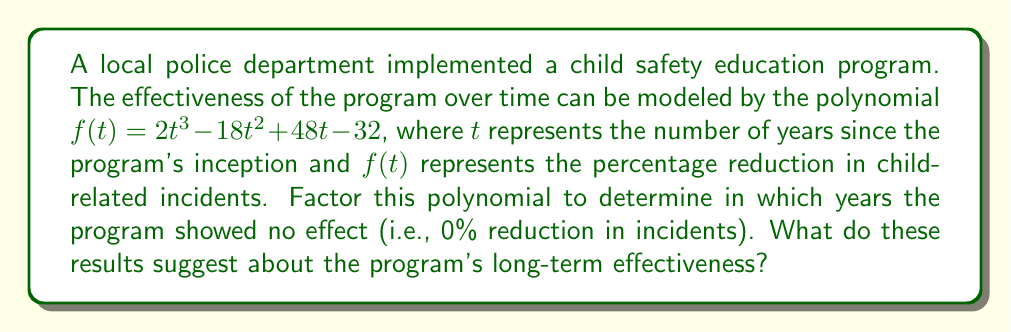Can you answer this question? To solve this problem, we need to factor the given polynomial and find its roots. The roots will represent the years when the program showed no effect.

1) First, let's try to factor out any common factors:
   $f(t) = 2t^3 - 18t^2 + 48t - 32$
   There are no common factors for all terms.

2) Next, we can try the rational root theorem. The possible rational roots are the factors of the constant term (32): ±1, ±2, ±4, ±8, ±16, ±32.

3) Testing these values, we find that $t = 2$ is a root. So $(t - 2)$ is a factor.

4) Divide the polynomial by $(t - 2)$:
   $\frac{2t^3 - 18t^2 + 48t - 32}{t - 2} = 2t^2 - 14t + 16$

5) The quadratic $2t^2 - 14t + 16$ can be factored further:
   $2t^2 - 14t + 16 = 2(t^2 - 7t + 8) = 2(t - 4)(t - 3)$

6) Therefore, the complete factorization is:
   $f(t) = 2(t - 2)(t - 3)(t - 4)$

7) The roots of this polynomial are $t = 2$, $t = 3$, and $t = 4$.

These results suggest that the program showed no effect (0% reduction in incidents) at 2, 3, and 4 years after its inception. The positive coefficient (2) indicates that the program's effectiveness increases after the 4-year mark, suggesting long-term benefits despite initial fluctuations.
Answer: The polynomial factors as $f(t) = 2(t - 2)(t - 3)(t - 4)$. The program showed no effect at 2, 3, and 4 years after implementation. The positive leading coefficient suggests improved long-term effectiveness beyond 4 years. 